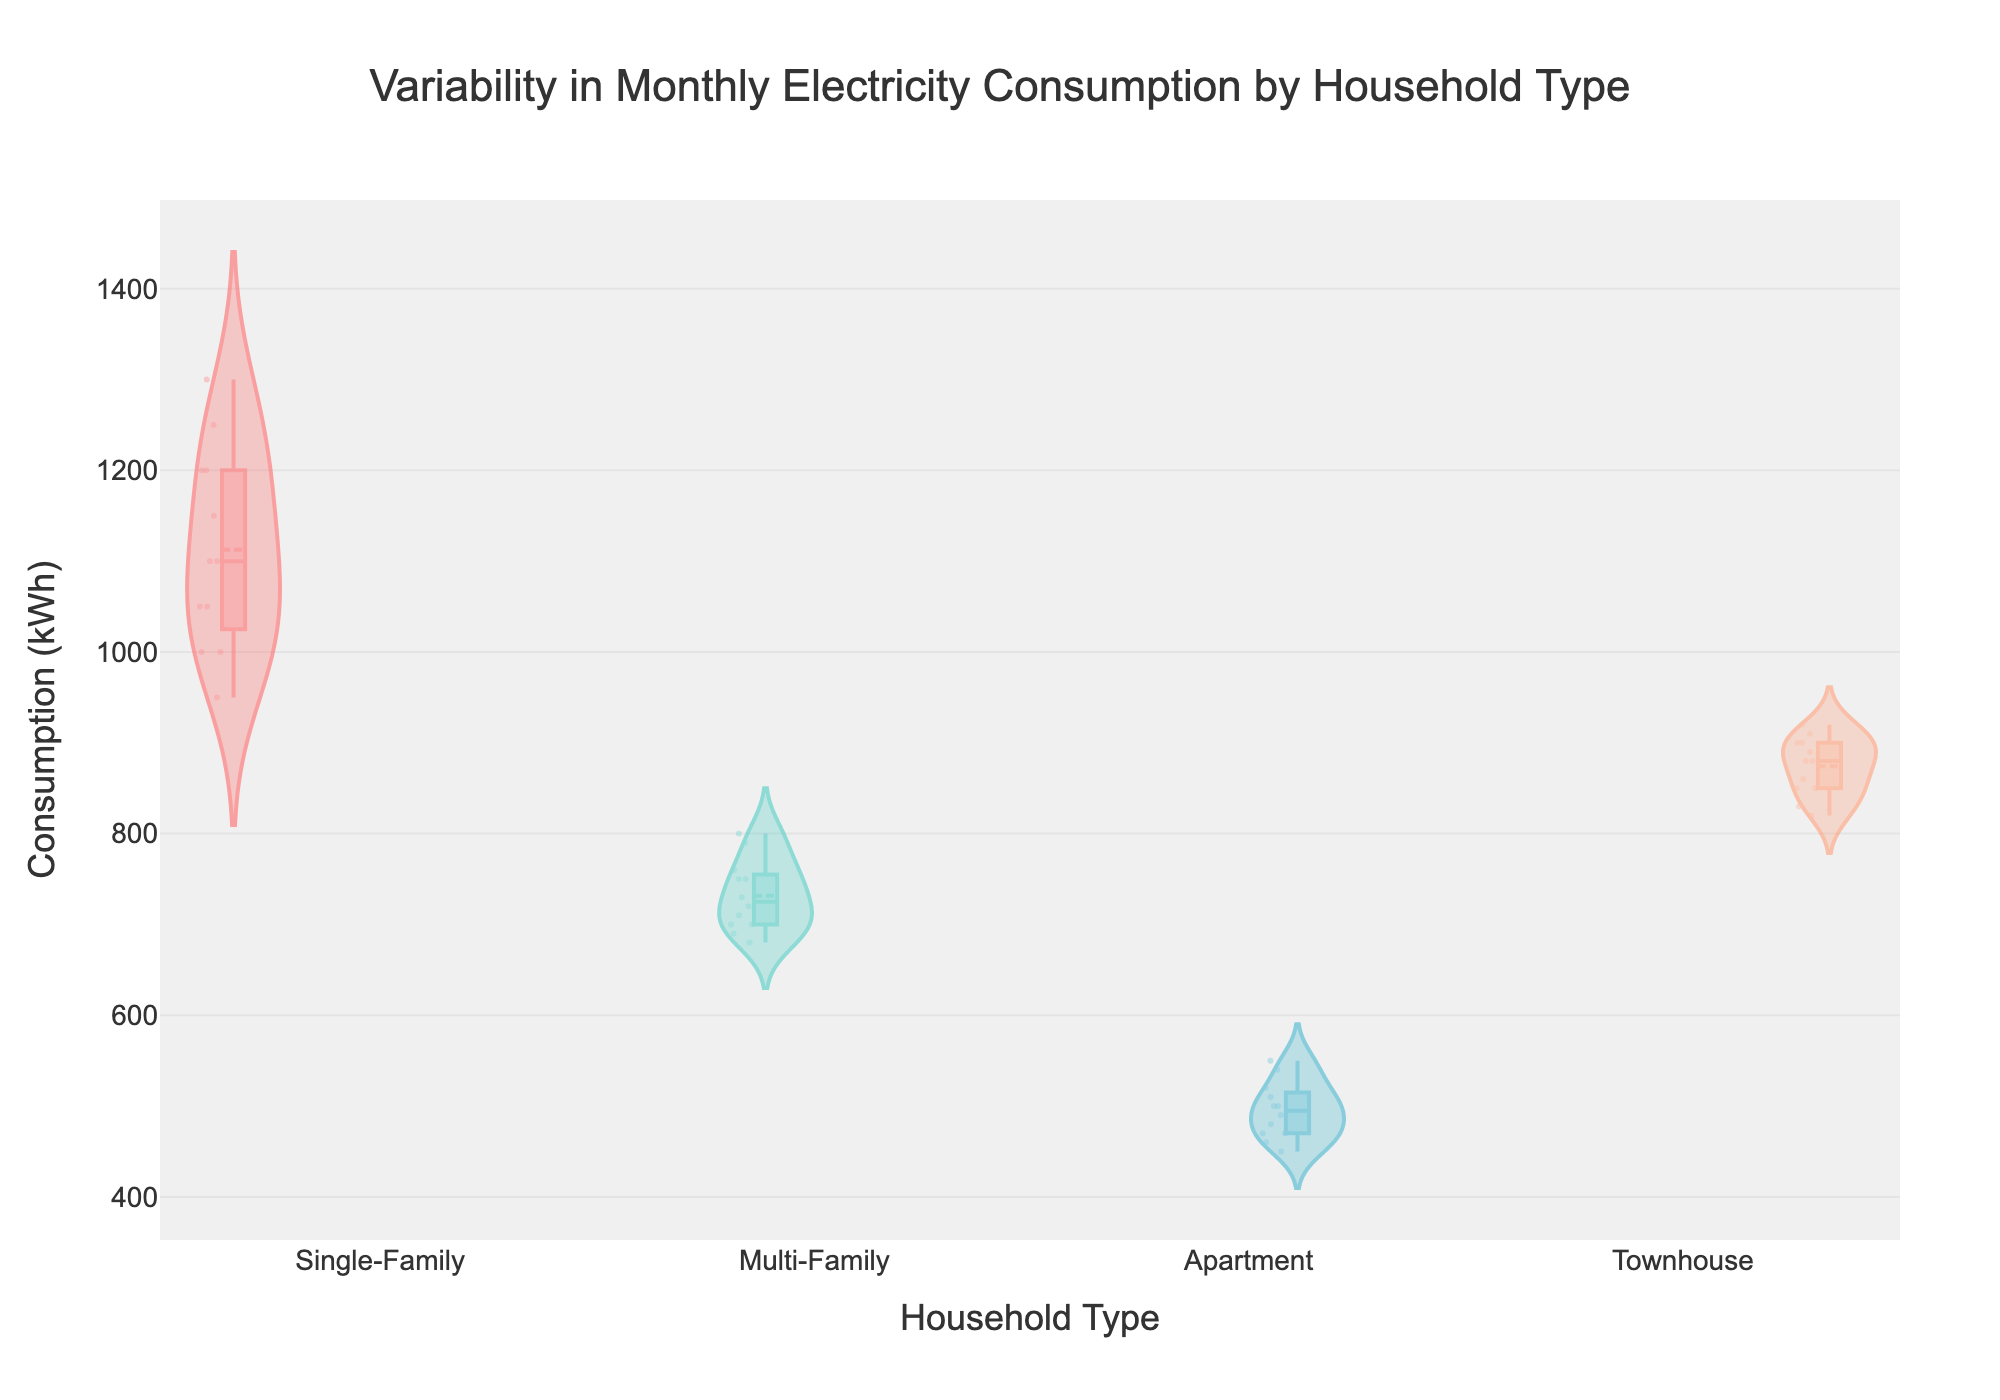what is the title of the figure? The title can be found at the top center of the figure. It reads "Variability in Monthly Electricity Consumption by Household Type."
Answer: Variability in Monthly Electricity Consumption by Household Type what types of households are compared in the figure? The x-axis labels of the figure show the types of households being compared. They are Single-Family, Multi-Family, Apartment, and Townhouse.
Answer: Single-Family, Multi-Family, Apartment, Townhouse which household type has the highest average monthly electricity consumption? The highest mean lines in the violin plots give the average consumption. The Single-Family household has the highest mean line.
Answer: Single-Family which household type has the lowest monthly electricity consumption in July? Look closely at the data points within the July sections of each household's box plot. The apartment household has the lowest data point in July.
Answer: Apartment which household types show the most variability in monthly electricity consumption? The violin plots that are wider along the y-axis indicate more variability in electricity consumption. The Single-Family household shows wider spread, indicating the most variability.
Answer: Single-Family what is the median monthly electricity consumption for Townhouses? Observe the central line within the Townhouse's box plot, which represents the median.
Answer: 880 kWh which household type has the most consistent monthly electricity consumption? The violin plot that is narrowest and has the least spread suggests consistency. The Apartment household has the most consistent electricity consumption.
Answer: Apartment how do the upper quartile values of Single-Family and Multi-Family households compare? The upper quartile values are given by the top edge of the boxes within each violin plot. The upper quartile value for Single-Family is higher than that for Multi-Family.
Answer: Single-Family is higher are outliers present in the monthly electricity consumption data for any households? Outliers, which are shown as individual points beyond the whiskers of the box plot, are not present in any household types.
Answer: No which household type has the lowest median monthly electricity consumption? The bottom of the central lines in each box plot represent the median. The Apartment household has the lowest median line.
Answer: Apartment 